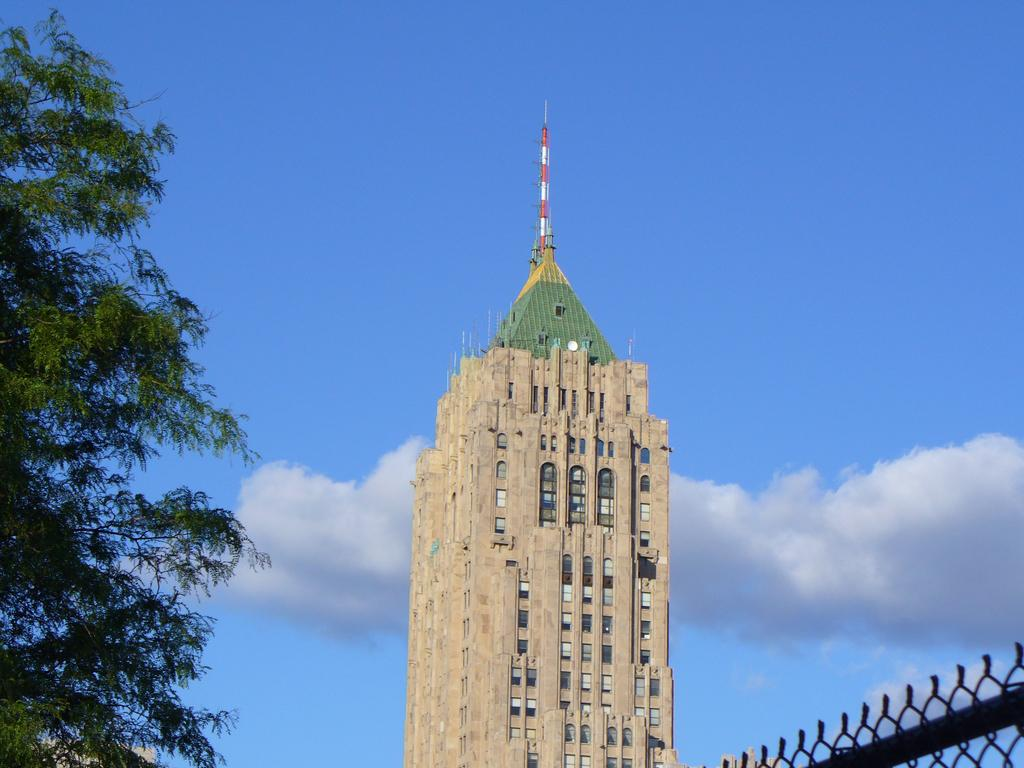What type of structure is present in the image? There is a building in the image. What feature can be seen on the building? The building has windows. What type of vegetation is visible in the image? There are trees in the image. What type of barrier is present in the image? There is net fencing in the image. What is the color of the sky in the image? The sky is blue and white in color. Is there any quicksand visible in the image? No, there is no quicksand present in the image. Can you spot any monkeys in the trees in the image? No, there are no monkeys visible in the image. 